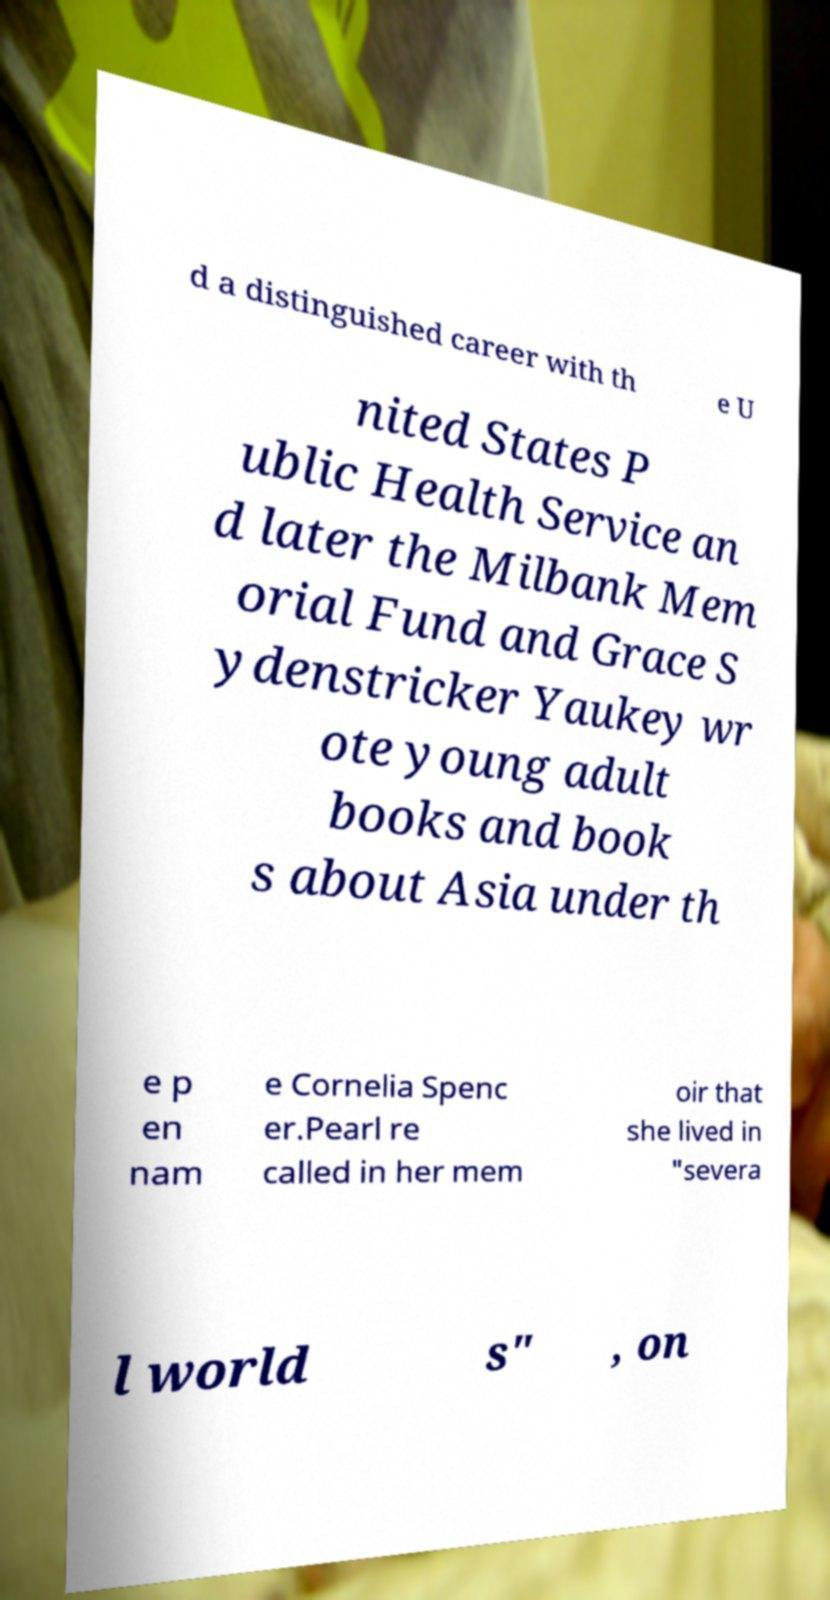Could you extract and type out the text from this image? d a distinguished career with th e U nited States P ublic Health Service an d later the Milbank Mem orial Fund and Grace S ydenstricker Yaukey wr ote young adult books and book s about Asia under th e p en nam e Cornelia Spenc er.Pearl re called in her mem oir that she lived in "severa l world s" , on 